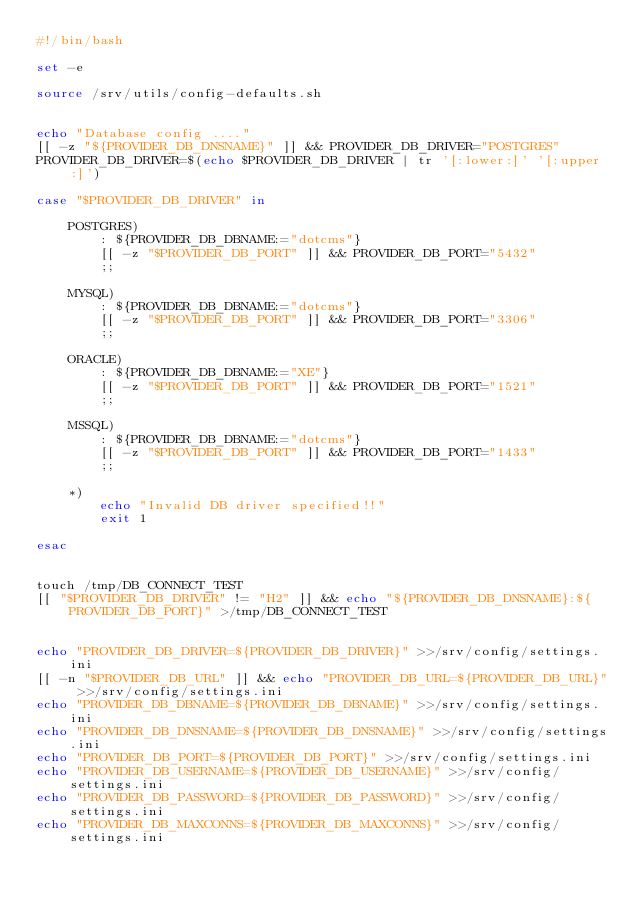Convert code to text. <code><loc_0><loc_0><loc_500><loc_500><_Bash_>#!/bin/bash

set -e

source /srv/utils/config-defaults.sh


echo "Database config ...."
[[ -z "${PROVIDER_DB_DNSNAME}" ]] && PROVIDER_DB_DRIVER="POSTGRES"
PROVIDER_DB_DRIVER=$(echo $PROVIDER_DB_DRIVER | tr '[:lower:]' '[:upper:]')

case "$PROVIDER_DB_DRIVER" in 

    POSTGRES)
        : ${PROVIDER_DB_DBNAME:="dotcms"}
        [[ -z "$PROVIDER_DB_PORT" ]] && PROVIDER_DB_PORT="5432"
        ;;

    MYSQL)
        : ${PROVIDER_DB_DBNAME:="dotcms"}
        [[ -z "$PROVIDER_DB_PORT" ]] && PROVIDER_DB_PORT="3306"
        ;;

    ORACLE)
        : ${PROVIDER_DB_DBNAME:="XE"}
        [[ -z "$PROVIDER_DB_PORT" ]] && PROVIDER_DB_PORT="1521"
        ;;

    MSSQL)
        : ${PROVIDER_DB_DBNAME:="dotcms"}
        [[ -z "$PROVIDER_DB_PORT" ]] && PROVIDER_DB_PORT="1433"
        ;;

    *)
        echo "Invalid DB driver specified!!"
        exit 1

esac


touch /tmp/DB_CONNECT_TEST
[[ "$PROVIDER_DB_DRIVER" != "H2" ]] && echo "${PROVIDER_DB_DNSNAME}:${PROVIDER_DB_PORT}" >/tmp/DB_CONNECT_TEST


echo "PROVIDER_DB_DRIVER=${PROVIDER_DB_DRIVER}" >>/srv/config/settings.ini
[[ -n "$PROVIDER_DB_URL" ]] && echo "PROVIDER_DB_URL=${PROVIDER_DB_URL}" >>/srv/config/settings.ini
echo "PROVIDER_DB_DBNAME=${PROVIDER_DB_DBNAME}" >>/srv/config/settings.ini
echo "PROVIDER_DB_DNSNAME=${PROVIDER_DB_DNSNAME}" >>/srv/config/settings.ini
echo "PROVIDER_DB_PORT=${PROVIDER_DB_PORT}" >>/srv/config/settings.ini
echo "PROVIDER_DB_USERNAME=${PROVIDER_DB_USERNAME}" >>/srv/config/settings.ini
echo "PROVIDER_DB_PASSWORD=${PROVIDER_DB_PASSWORD}" >>/srv/config/settings.ini
echo "PROVIDER_DB_MAXCONNS=${PROVIDER_DB_MAXCONNS}" >>/srv/config/settings.ini




</code> 